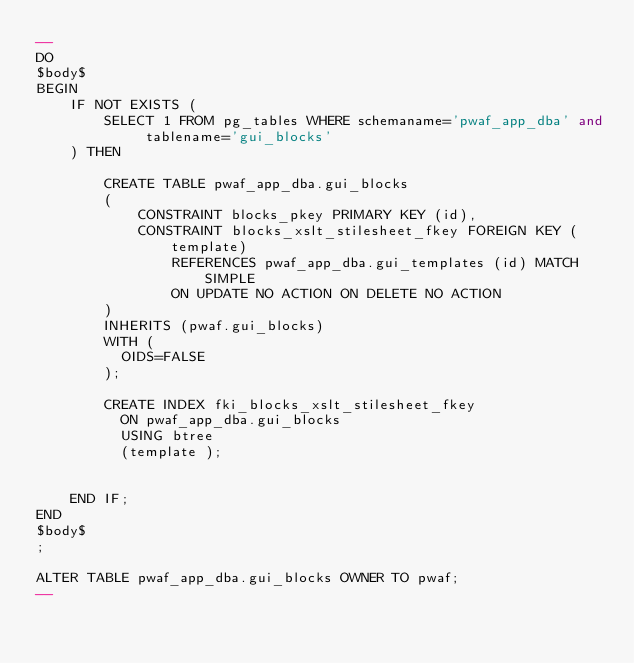Convert code to text. <code><loc_0><loc_0><loc_500><loc_500><_SQL_>--
DO
$body$
BEGIN
	IF NOT EXISTS (
		SELECT 1 FROM pg_tables WHERE schemaname='pwaf_app_dba' and tablename='gui_blocks'
	) THEN

		CREATE TABLE pwaf_app_dba.gui_blocks
		(
		  	CONSTRAINT blocks_pkey PRIMARY KEY (id),
		  	CONSTRAINT blocks_xslt_stilesheet_fkey FOREIGN KEY (template)
      			REFERENCES pwaf_app_dba.gui_templates (id) MATCH SIMPLE
      			ON UPDATE NO ACTION ON DELETE NO ACTION
		)
		INHERITS (pwaf.gui_blocks)
		WITH (
		  OIDS=FALSE
		);

		CREATE INDEX fki_blocks_xslt_stilesheet_fkey
		  ON pwaf_app_dba.gui_blocks
		  USING btree
		  (template );


	END IF;
END
$body$
;

ALTER TABLE pwaf_app_dba.gui_blocks OWNER TO pwaf;
--</code> 